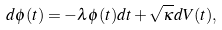<formula> <loc_0><loc_0><loc_500><loc_500>d \phi ( t ) = - \lambda \phi ( t ) d t + \sqrt { \kappa } d V ( t ) ,</formula> 